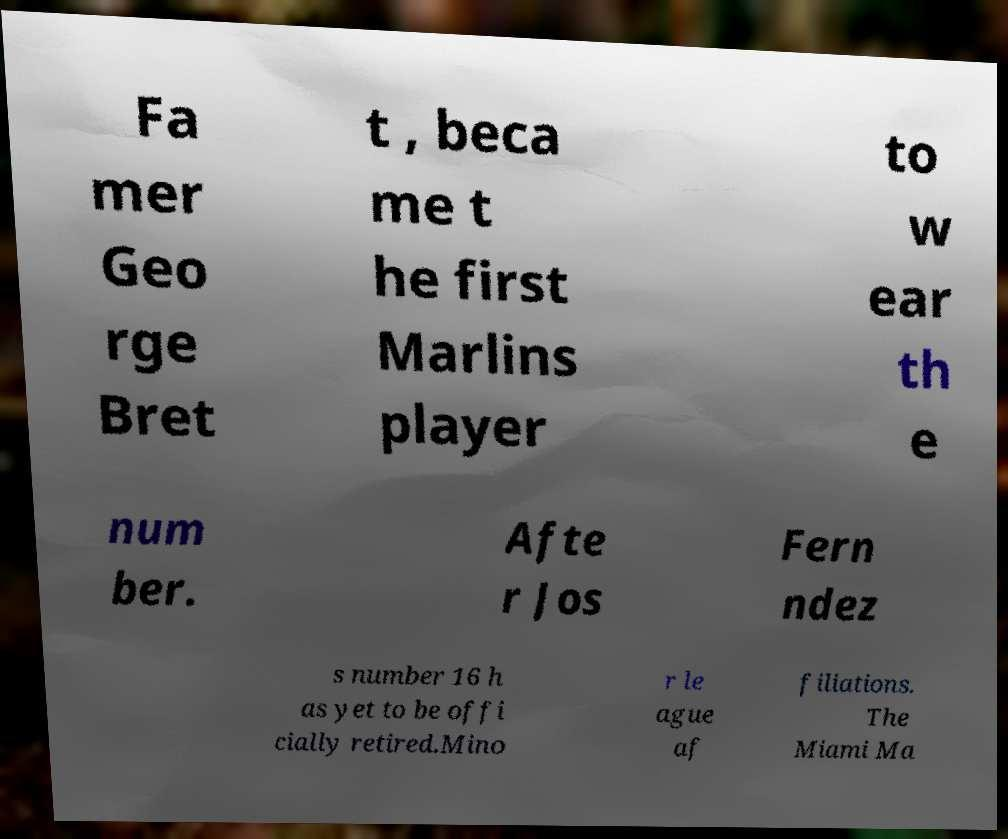Can you accurately transcribe the text from the provided image for me? Fa mer Geo rge Bret t , beca me t he first Marlins player to w ear th e num ber. Afte r Jos Fern ndez s number 16 h as yet to be offi cially retired.Mino r le ague af filiations. The Miami Ma 